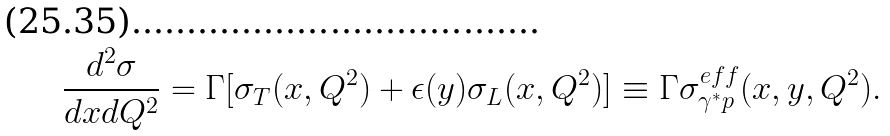Convert formula to latex. <formula><loc_0><loc_0><loc_500><loc_500>\frac { d ^ { 2 } \sigma } { d x d Q ^ { 2 } } = \Gamma [ \sigma _ { T } ( x , Q ^ { 2 } ) + \epsilon ( y ) \sigma _ { L } ( x , Q ^ { 2 } ) ] \equiv \Gamma \sigma ^ { e f f } _ { \gamma ^ { * } p } ( x , y , Q ^ { 2 } ) .</formula> 